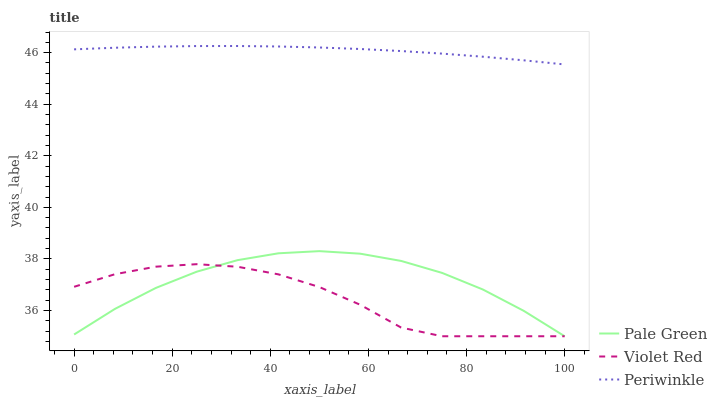Does Violet Red have the minimum area under the curve?
Answer yes or no. Yes. Does Periwinkle have the maximum area under the curve?
Answer yes or no. Yes. Does Pale Green have the minimum area under the curve?
Answer yes or no. No. Does Pale Green have the maximum area under the curve?
Answer yes or no. No. Is Periwinkle the smoothest?
Answer yes or no. Yes. Is Violet Red the roughest?
Answer yes or no. Yes. Is Pale Green the smoothest?
Answer yes or no. No. Is Pale Green the roughest?
Answer yes or no. No. Does Violet Red have the lowest value?
Answer yes or no. Yes. Does Periwinkle have the lowest value?
Answer yes or no. No. Does Periwinkle have the highest value?
Answer yes or no. Yes. Does Pale Green have the highest value?
Answer yes or no. No. Is Pale Green less than Periwinkle?
Answer yes or no. Yes. Is Periwinkle greater than Violet Red?
Answer yes or no. Yes. Does Pale Green intersect Violet Red?
Answer yes or no. Yes. Is Pale Green less than Violet Red?
Answer yes or no. No. Is Pale Green greater than Violet Red?
Answer yes or no. No. Does Pale Green intersect Periwinkle?
Answer yes or no. No. 